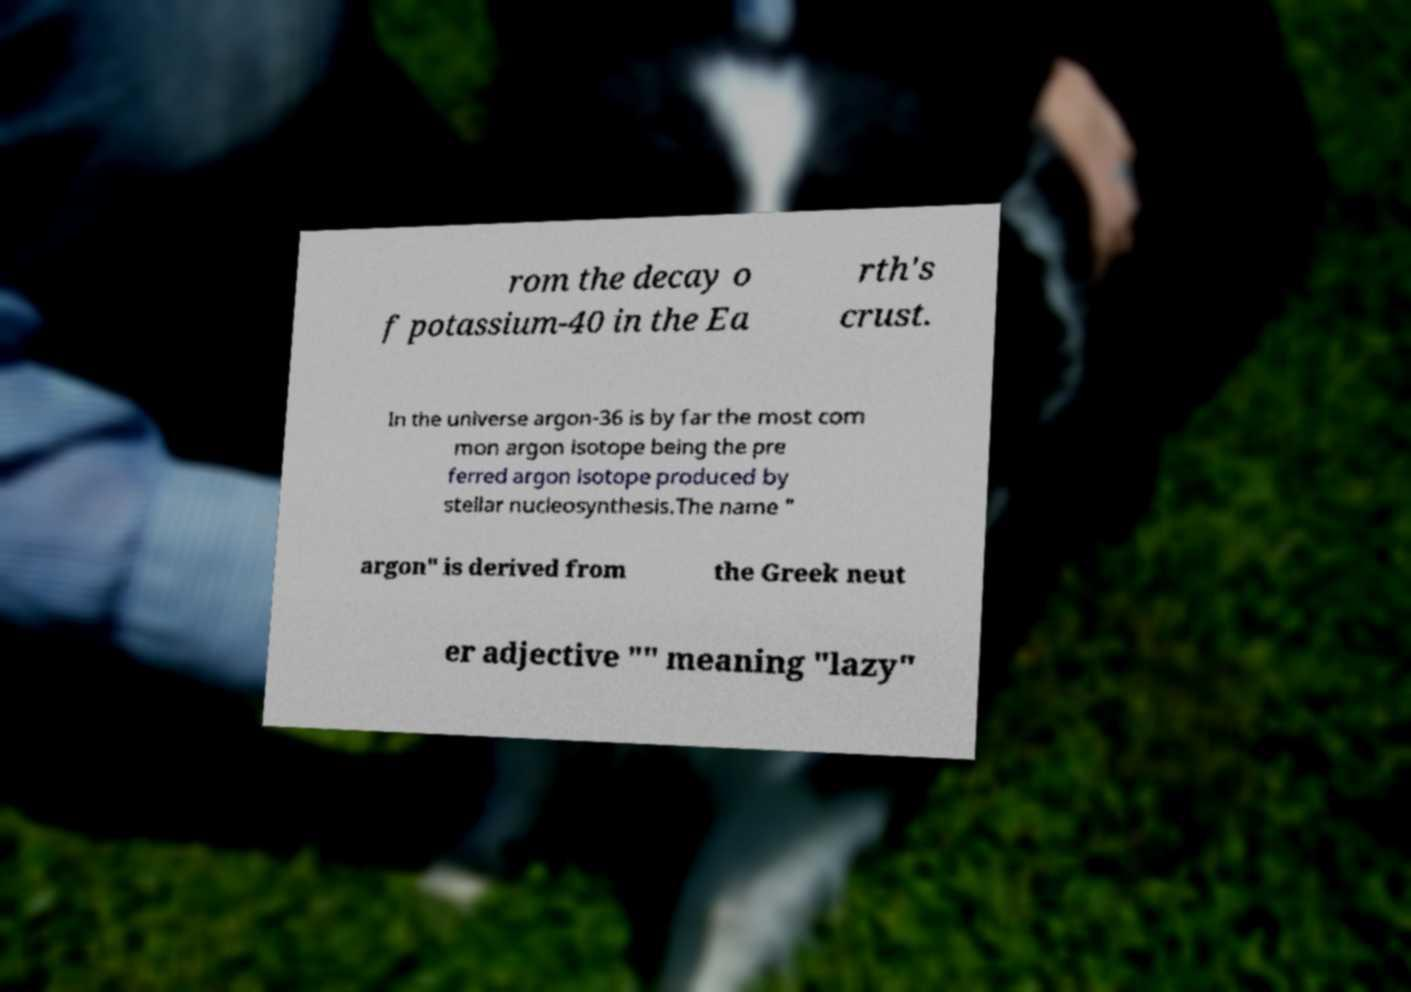For documentation purposes, I need the text within this image transcribed. Could you provide that? rom the decay o f potassium-40 in the Ea rth's crust. In the universe argon-36 is by far the most com mon argon isotope being the pre ferred argon isotope produced by stellar nucleosynthesis.The name " argon" is derived from the Greek neut er adjective "" meaning "lazy" 